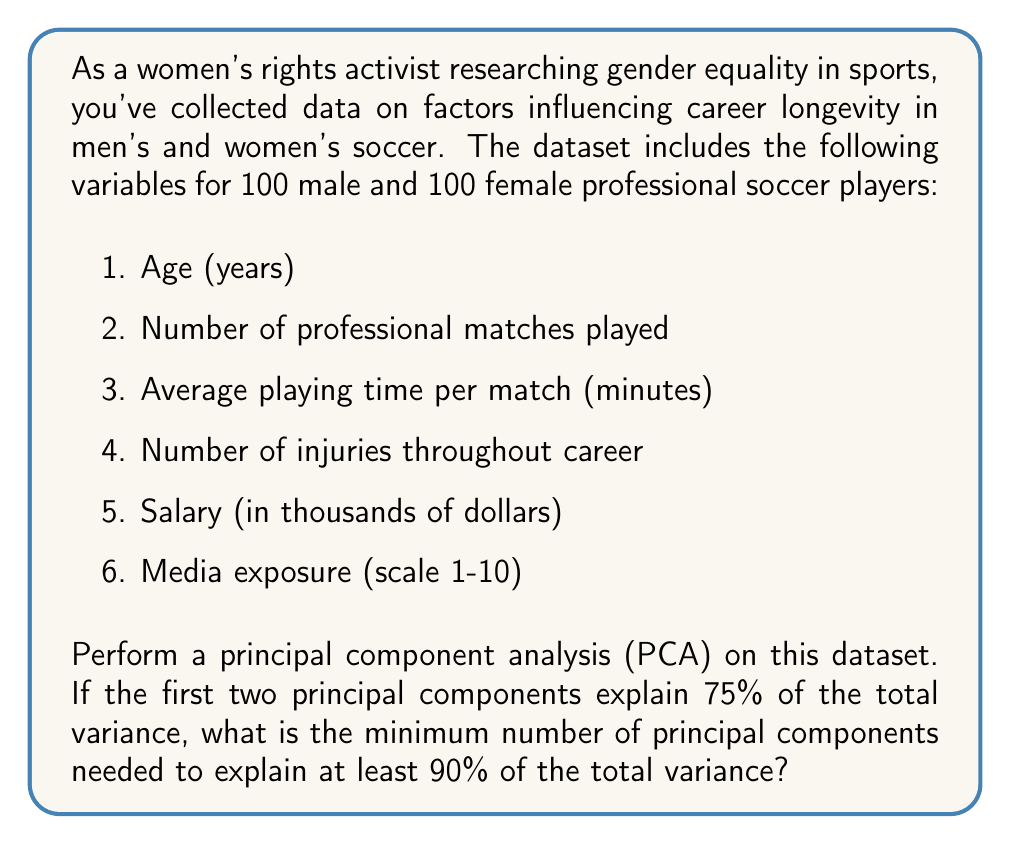Can you answer this question? To solve this problem, we need to understand the concept of principal component analysis (PCA) and cumulative explained variance. Let's break it down step by step:

1. Principal Component Analysis (PCA):
   PCA is a dimensionality reduction technique that transforms a set of correlated variables into a smaller set of uncorrelated variables called principal components. These components are ordered by the amount of variance they explain in the original dataset.

2. Explained Variance:
   Each principal component explains a certain percentage of the total variance in the dataset. The explained variance is typically expressed as a proportion or percentage.

3. Cumulative Explained Variance:
   This is the sum of the explained variances of the principal components, starting from the first component and adding each subsequent component's contribution.

4. Given Information:
   - The first two principal components explain 75% of the total variance.
   - We need to find the minimum number of components to explain at least 90% of the total variance.

5. Calculation:
   Let's denote the explained variance of each principal component as $EV_i$, where $i$ is the component number.

   We know:
   $$EV_1 + EV_2 = 0.75$$

   The remaining variance to be explained is:
   $$1 - 0.75 = 0.25$$

   This 25% needs to be distributed among the remaining components (PC3 to PC6, as we have 6 variables in total).

   To reach 90%, we need to explain an additional:
   $$0.90 - 0.75 = 0.15$$

   Even if the third component explains less variance than the second, it will certainly explain more than 15% of the total variance, given that there's only 25% left to explain among 4 components.

Therefore, adding the third principal component will push the cumulative explained variance over 90%.
Answer: The minimum number of principal components needed to explain at least 90% of the total variance is 3. 